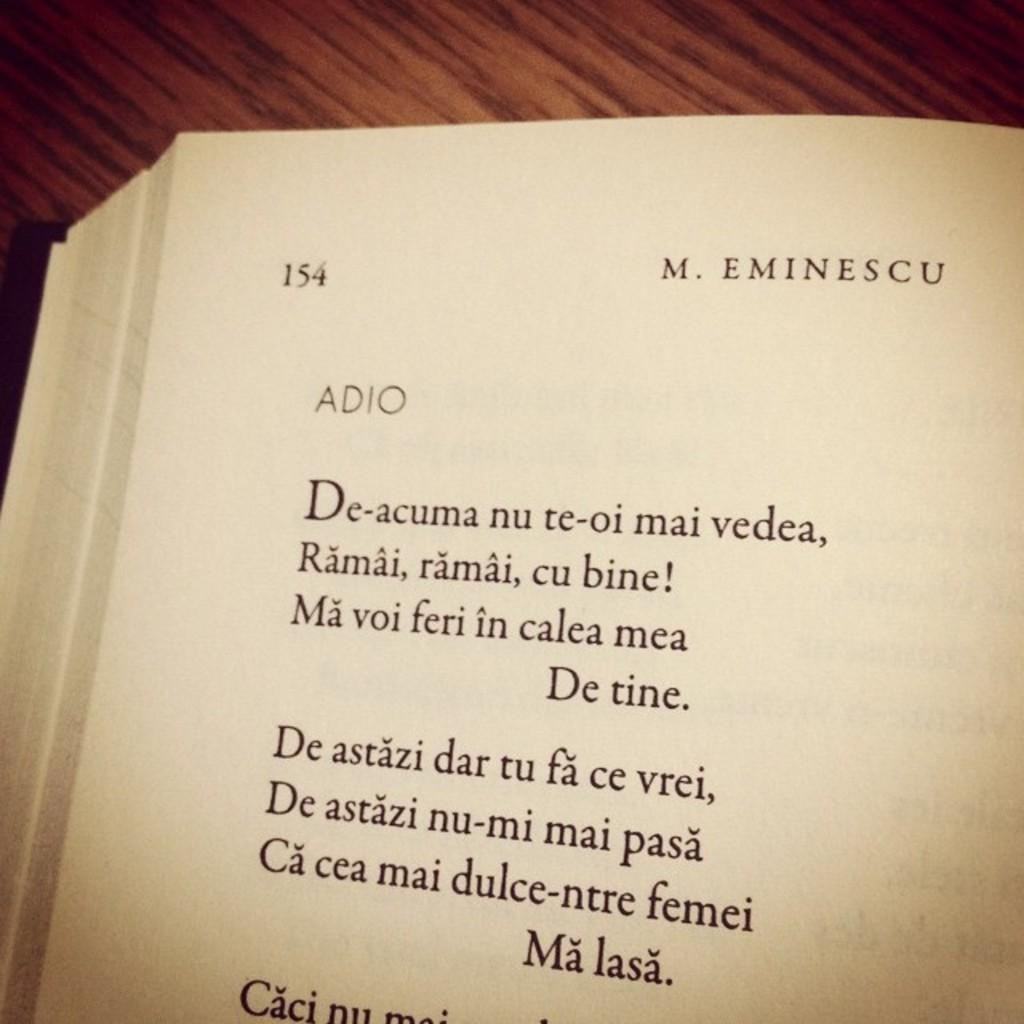<image>
Create a compact narrative representing the image presented. A book is open to page 154 that says M. Eminescu. 